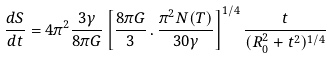Convert formula to latex. <formula><loc_0><loc_0><loc_500><loc_500>\frac { d S } { d t } = 4 \pi ^ { 2 } \frac { 3 \gamma } { 8 \pi G } \left [ \frac { 8 \pi G } { 3 } \, { . } \, \frac { \pi ^ { 2 } N ( T ) } { 3 0 \gamma } \right ] ^ { 1 / 4 } \frac { t } { ( R _ { 0 } ^ { 2 } + t ^ { 2 } ) ^ { 1 / 4 } }</formula> 